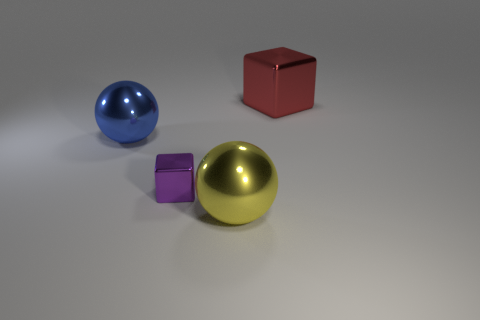Add 2 large blue metal spheres. How many objects exist? 6 Subtract all yellow spheres. How many spheres are left? 1 Add 2 big things. How many big things are left? 5 Add 2 large purple cubes. How many large purple cubes exist? 2 Subtract 1 purple blocks. How many objects are left? 3 Subtract all yellow blocks. Subtract all red cylinders. How many blocks are left? 2 Subtract all cyan blocks. How many green spheres are left? 0 Subtract all red shiny blocks. Subtract all purple objects. How many objects are left? 2 